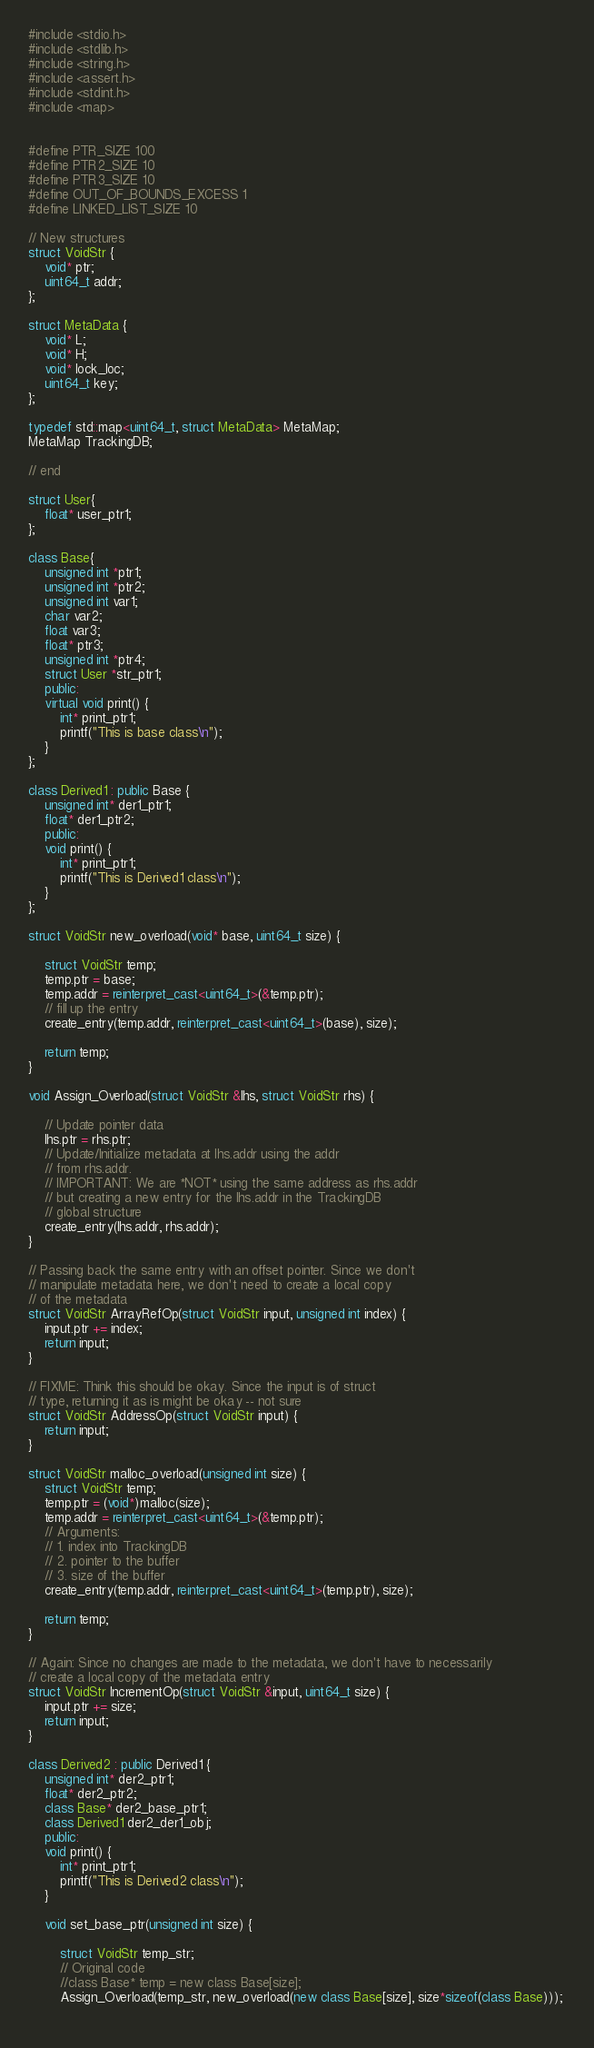<code> <loc_0><loc_0><loc_500><loc_500><_C++_>#include <stdio.h>
#include <stdlib.h>
#include <string.h>
#include <assert.h>
#include <stdint.h>
#include <map>


#define PTR_SIZE 100
#define PTR2_SIZE 10
#define PTR3_SIZE 10
#define OUT_OF_BOUNDS_EXCESS 1
#define LINKED_LIST_SIZE 10

// New structures
struct VoidStr {
    void* ptr;
    uint64_t addr;
};

struct MetaData {
    void* L;
    void* H;
    void* lock_loc;
    uint64_t key;
};

typedef std::map<uint64_t, struct MetaData> MetaMap;
MetaMap TrackingDB;

// end

struct User{
    float* user_ptr1;
};

class Base{
    unsigned int *ptr1;
    unsigned int *ptr2;
    unsigned int var1;
    char var2;
    float var3;
    float* ptr3;
    unsigned int *ptr4;
    struct User *str_ptr1;
    public:
    virtual void print() {
        int* print_ptr1;
        printf("This is base class\n");
    }
};

class Derived1 : public Base {
    unsigned int* der1_ptr1;
    float* der1_ptr2;
    public:
    void print() {
        int* print_ptr1;
        printf("This is Derived1 class\n");
    }
};

struct VoidStr new_overload(void* base, uint64_t size) {
    
    struct VoidStr temp;
    temp.ptr = base;
    temp.addr = reinterpret_cast<uint64_t>(&temp.ptr);
    // fill up the entry 
    create_entry(temp.addr, reinterpret_cast<uint64_t>(base), size);    

    return temp;
}

void Assign_Overload(struct VoidStr &lhs, struct VoidStr rhs) {
    
    // Update pointer data    
    lhs.ptr = rhs.ptr;
    // Update/Initialize metadata at lhs.addr using the addr
    // from rhs.addr. 
    // IMPORTANT: We are *NOT* using the same address as rhs.addr
    // but creating a new entry for the lhs.addr in the TrackingDB
    // global structure
    create_entry(lhs.addr, rhs.addr);
}

// Passing back the same entry with an offset pointer. Since we don't
// manipulate metadata here, we don't need to create a local copy 
// of the metadata
struct VoidStr ArrayRefOp(struct VoidStr input, unsigned int index) {
    input.ptr += index;
    return input;
}

// FIXME: Think this should be okay. Since the input is of struct
// type, returning it as is might be okay -- not sure
struct VoidStr AddressOp(struct VoidStr input) {
    return input;
}

struct VoidStr malloc_overload(unsigned int size) {
    struct VoidStr temp;
    temp.ptr = (void*)malloc(size);
    temp.addr = reinterpret_cast<uint64_t>(&temp.ptr);
    // Arguments:
    // 1. index into TrackingDB
    // 2. pointer to the buffer
    // 3. size of the buffer
    create_entry(temp.addr, reinterpret_cast<uint64_t>(temp.ptr), size);
    
    return temp;
}

// Again: Since no changes are made to the metadata, we don't have to necessarily
// create a local copy of the metadata entry
struct VoidStr IncrementOp(struct VoidStr &input, uint64_t size) {
    input.ptr += size;
    return input;
}

class Derived2 : public Derived1 {
    unsigned int* der2_ptr1;
    float* der2_ptr2;
    class Base* der2_base_ptr1;
    class Derived1 der2_der1_obj;
    public:
    void print() {
        int* print_ptr1;
        printf("This is Derived2 class\n");
    }

    void set_base_ptr(unsigned int size) {
    
        struct VoidStr temp_str;
        // Original code
        //class Base* temp = new class Base[size];
        Assign_Overload(temp_str, new_overload(new class Base[size], size*sizeof(class Base))); 
        </code> 